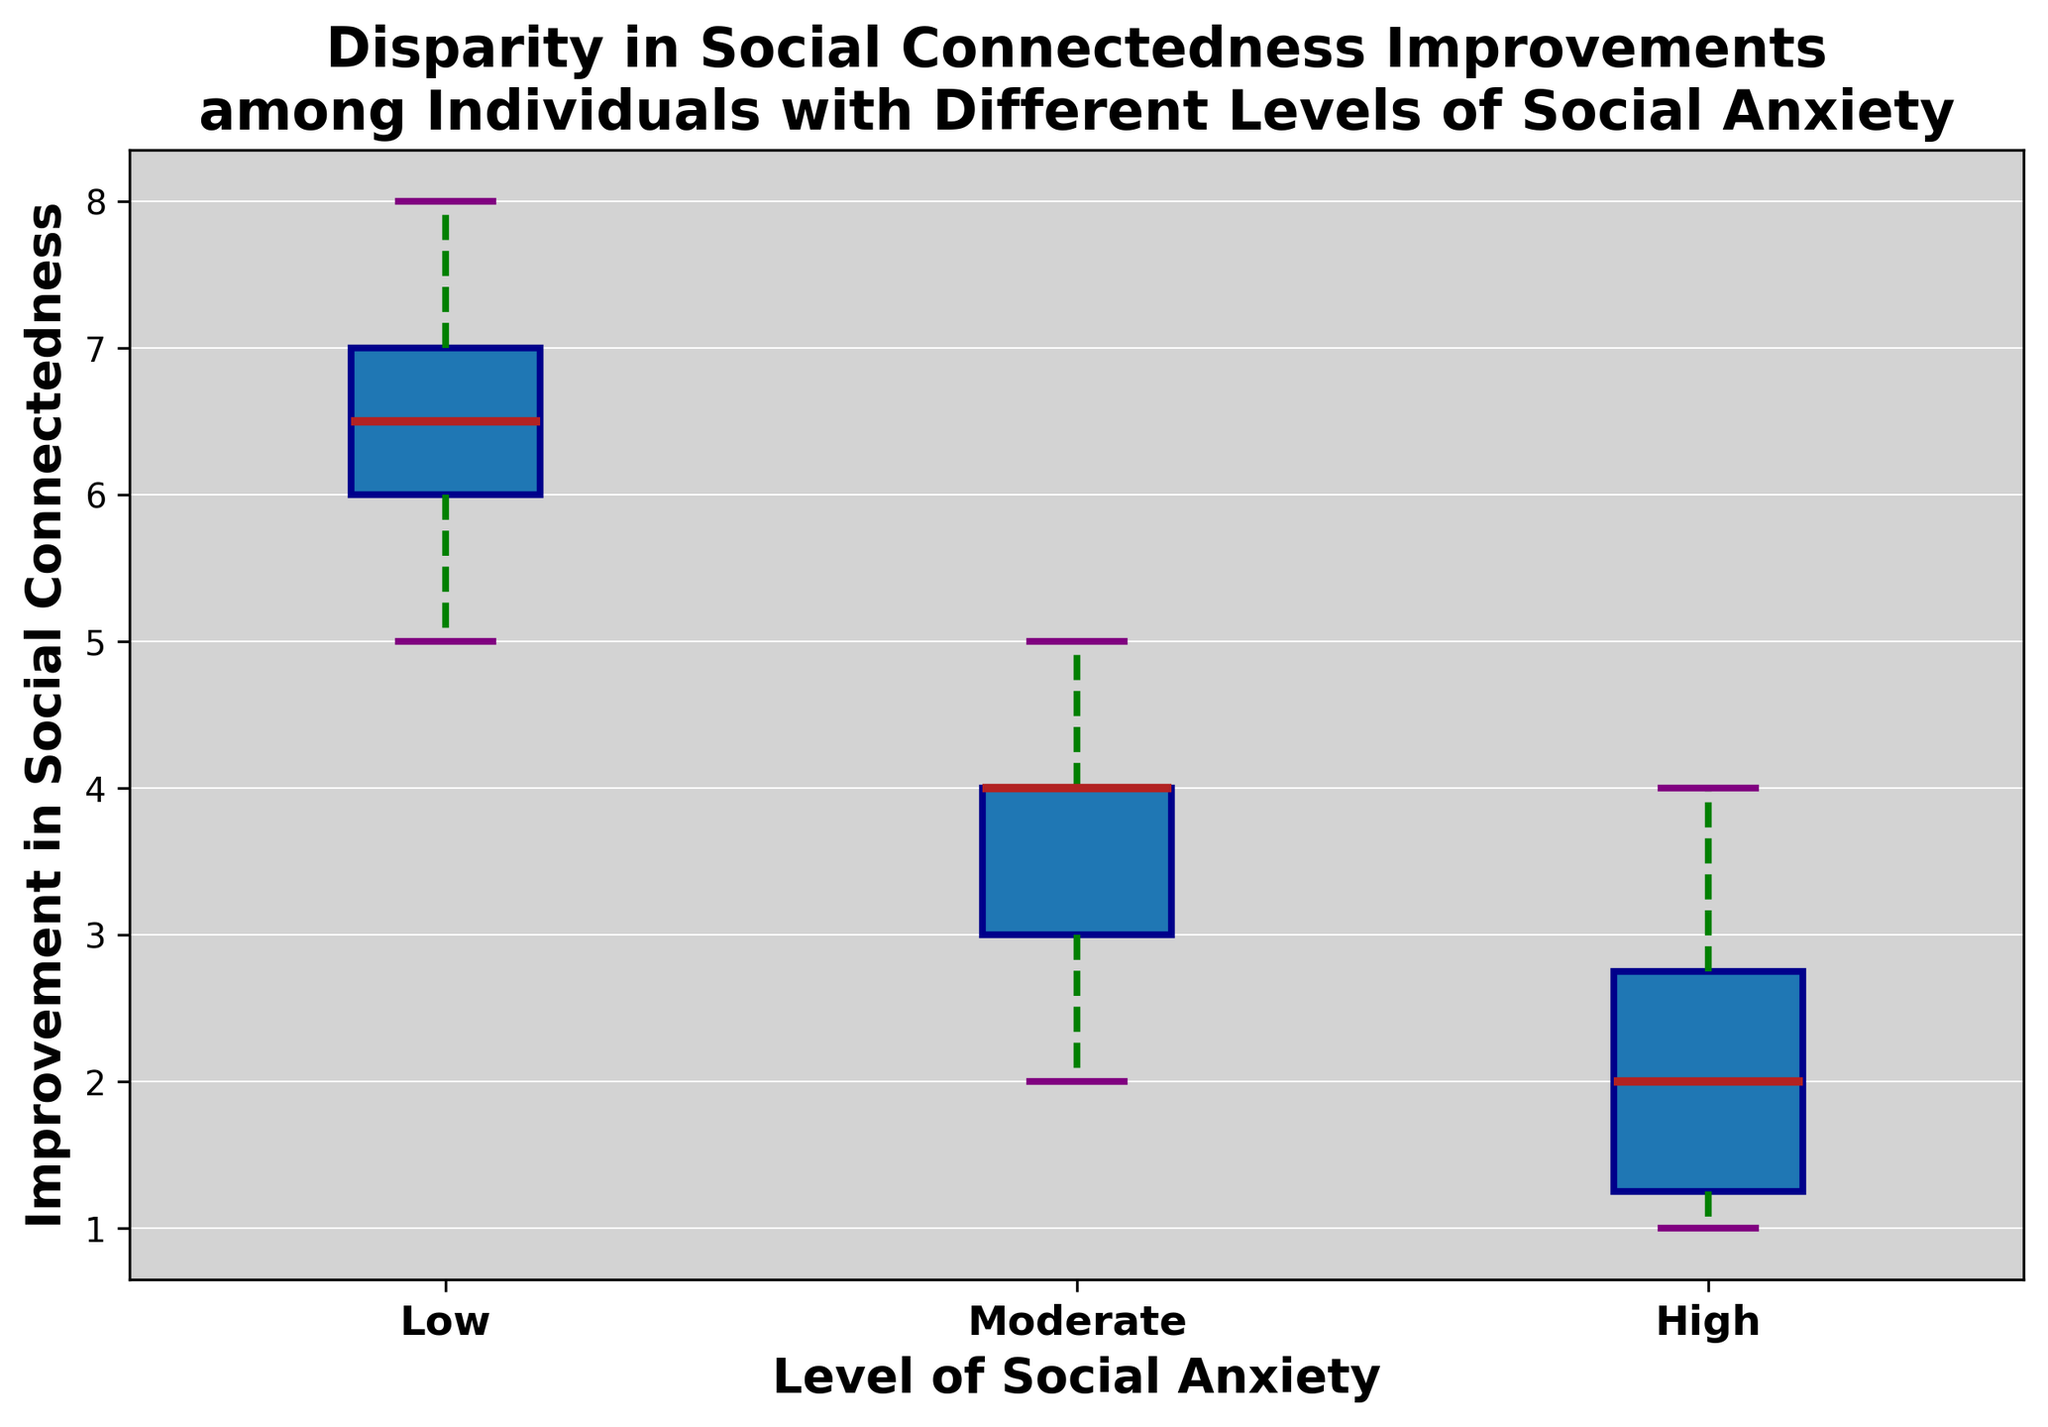what is the median improvement in social connectedness for individuals with low social anxiety? The median is the middle value when the data is ordered from least to most. For low social anxiety: 5, 5, 6, 6, 6, 7, 7, 7, 8, 8. The median is the average of the 5th and 6th values, (6 + 7) / 2 = 6.5.
Answer: 6.5 Which group has the highest median improvement in social connectedness? Locate the median line in each box in the box plot. The highest median is for low social anxiety group.
Answer: Low Social Anxiety How does the range of improvements for individuals with moderate social anxiety compare to those with high social anxiety? The range is the difference between the maximum and minimum values within the whiskers. Moderate: 5 - 2 = 3, High: 4 - 1 = 3. Both groups have the same range of 3.
Answer: Same Which group has the widest interquartile range (IQR) of improvements? IQR is the difference between the third quartile (Q3) and the first quartile (Q1). By looking at the width of the boxes, low social anxiety has the widest IQR.
Answer: Low Social Anxiety What is the minimum and maximum value for the high social anxiety group? The minimum and maximum are shown by the bottom and top whiskers, respectively. For high social anxiety: minimum is 1 and maximum is 4.
Answer: 1 and 4 When comparing the whiskers' lengths, which group shows the most variability in improvements? Variability can be assessed by the whisker length. The moderate social anxiety group has longer whiskers compared to the others.
Answer: Moderate Social Anxiety Which group's median improvement is closer to its third quartile? For the median to be closer to the third quartile, the upper half of the box should be shorter. In this case, high social anxiety has a shorter distance from median to Q3 than from median to Q1.
Answer: High Social Anxiety Does any group have an improvement value that appears as an outlier? An outlier would be an individual point outside the whiskers. None of the groups show outliers; all values appear within the whiskers.
Answer: No outliers 